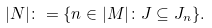Convert formula to latex. <formula><loc_0><loc_0><loc_500><loc_500>| N | \colon = \{ n \in | M | \colon J \subseteq J _ { n } \} .</formula> 